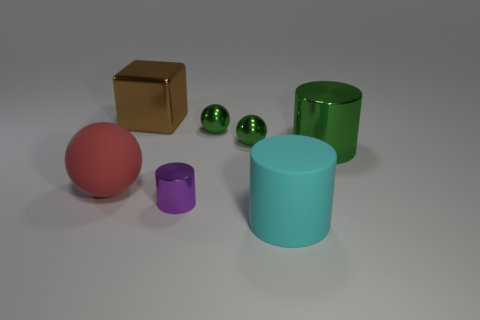What number of objects are balls on the right side of the big metallic block or big brown objects?
Your answer should be very brief. 3. Does the red matte sphere have the same size as the purple thing?
Offer a terse response. No. There is a tiny metal thing that is in front of the big sphere; what color is it?
Keep it short and to the point. Purple. The purple cylinder that is made of the same material as the brown object is what size?
Your answer should be very brief. Small. There is a rubber sphere; is it the same size as the cylinder that is right of the cyan cylinder?
Make the answer very short. Yes. There is a red ball that is behind the matte cylinder; what is its material?
Make the answer very short. Rubber. How many large things are to the right of the rubber thing that is right of the tiny purple cylinder?
Your response must be concise. 1. Are there any big objects of the same shape as the small purple object?
Keep it short and to the point. Yes. Is the size of the matte object that is on the left side of the cyan cylinder the same as the metal cylinder on the left side of the cyan object?
Your answer should be very brief. No. There is a large metal thing behind the large cylinder behind the tiny purple metal object; what shape is it?
Provide a succinct answer. Cube. 